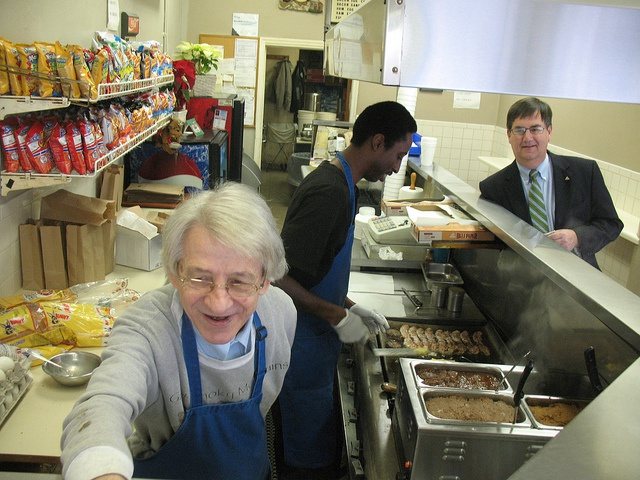Describe the objects in this image and their specific colors. I can see people in gray, darkgray, black, and beige tones, oven in gray, black, and darkgreen tones, people in gray, black, and navy tones, people in gray, black, and darkgray tones, and refrigerator in gray, black, maroon, brown, and darkgray tones in this image. 